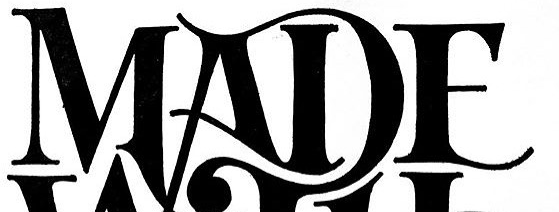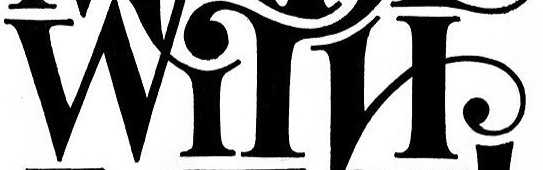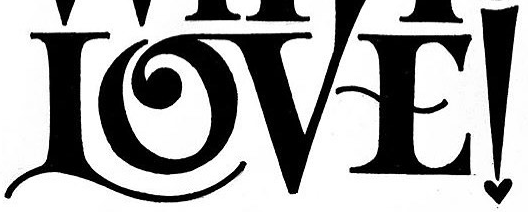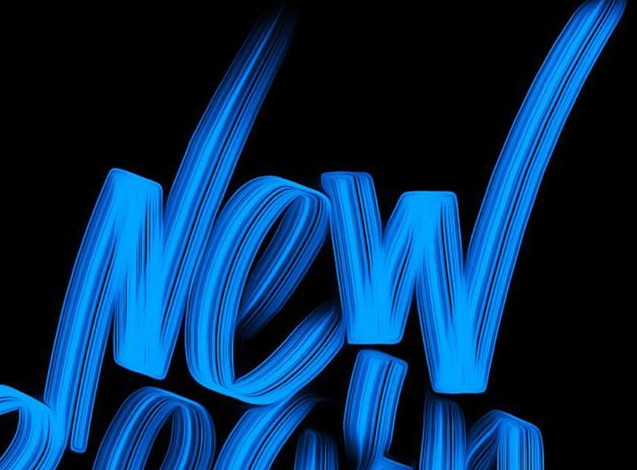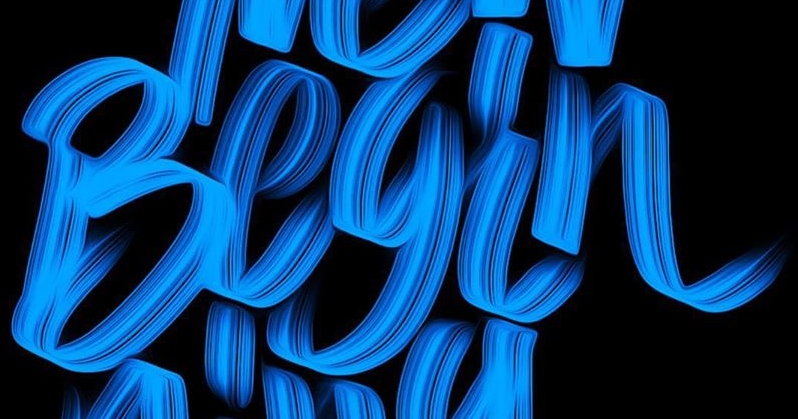What text is displayed in these images sequentially, separated by a semicolon? MADE; WITH; LOVE!; New; Begin 